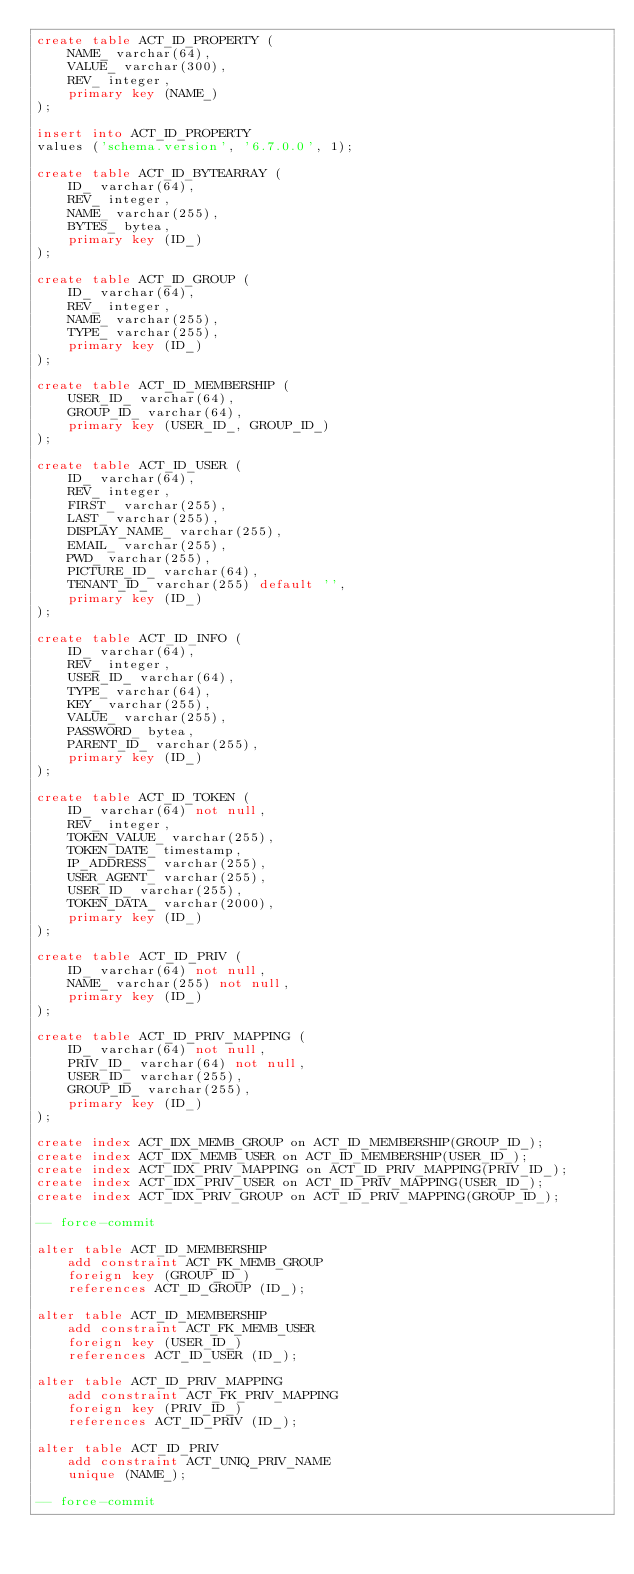<code> <loc_0><loc_0><loc_500><loc_500><_SQL_>create table ACT_ID_PROPERTY (
    NAME_ varchar(64),
    VALUE_ varchar(300),
    REV_ integer,
    primary key (NAME_)
);

insert into ACT_ID_PROPERTY
values ('schema.version', '6.7.0.0', 1);

create table ACT_ID_BYTEARRAY (
    ID_ varchar(64),
    REV_ integer,
    NAME_ varchar(255),
    BYTES_ bytea,
    primary key (ID_)
);

create table ACT_ID_GROUP (
    ID_ varchar(64),
    REV_ integer,
    NAME_ varchar(255),
    TYPE_ varchar(255),
    primary key (ID_)
);

create table ACT_ID_MEMBERSHIP (
    USER_ID_ varchar(64),
    GROUP_ID_ varchar(64),
    primary key (USER_ID_, GROUP_ID_)
);

create table ACT_ID_USER (
    ID_ varchar(64),
    REV_ integer,
    FIRST_ varchar(255),
    LAST_ varchar(255),
    DISPLAY_NAME_ varchar(255),
    EMAIL_ varchar(255),
    PWD_ varchar(255),
    PICTURE_ID_ varchar(64),
    TENANT_ID_ varchar(255) default '',
    primary key (ID_)
);

create table ACT_ID_INFO (
    ID_ varchar(64),
    REV_ integer,
    USER_ID_ varchar(64),
    TYPE_ varchar(64),
    KEY_ varchar(255),
    VALUE_ varchar(255),
    PASSWORD_ bytea,
    PARENT_ID_ varchar(255),
    primary key (ID_)
);

create table ACT_ID_TOKEN (
    ID_ varchar(64) not null,
    REV_ integer,
    TOKEN_VALUE_ varchar(255),
    TOKEN_DATE_ timestamp,
    IP_ADDRESS_ varchar(255),
    USER_AGENT_ varchar(255),
    USER_ID_ varchar(255),
    TOKEN_DATA_ varchar(2000),
    primary key (ID_)
);

create table ACT_ID_PRIV (
    ID_ varchar(64) not null,
    NAME_ varchar(255) not null,
    primary key (ID_)
);

create table ACT_ID_PRIV_MAPPING (
    ID_ varchar(64) not null,
    PRIV_ID_ varchar(64) not null,
    USER_ID_ varchar(255),
    GROUP_ID_ varchar(255),
    primary key (ID_)
);

create index ACT_IDX_MEMB_GROUP on ACT_ID_MEMBERSHIP(GROUP_ID_);
create index ACT_IDX_MEMB_USER on ACT_ID_MEMBERSHIP(USER_ID_);
create index ACT_IDX_PRIV_MAPPING on ACT_ID_PRIV_MAPPING(PRIV_ID_);
create index ACT_IDX_PRIV_USER on ACT_ID_PRIV_MAPPING(USER_ID_);
create index ACT_IDX_PRIV_GROUP on ACT_ID_PRIV_MAPPING(GROUP_ID_);

-- force-commit

alter table ACT_ID_MEMBERSHIP
    add constraint ACT_FK_MEMB_GROUP
    foreign key (GROUP_ID_)
    references ACT_ID_GROUP (ID_);

alter table ACT_ID_MEMBERSHIP
    add constraint ACT_FK_MEMB_USER
    foreign key (USER_ID_)
    references ACT_ID_USER (ID_);

alter table ACT_ID_PRIV_MAPPING
    add constraint ACT_FK_PRIV_MAPPING
    foreign key (PRIV_ID_)
    references ACT_ID_PRIV (ID_);

alter table ACT_ID_PRIV
    add constraint ACT_UNIQ_PRIV_NAME
    unique (NAME_);

-- force-commit</code> 